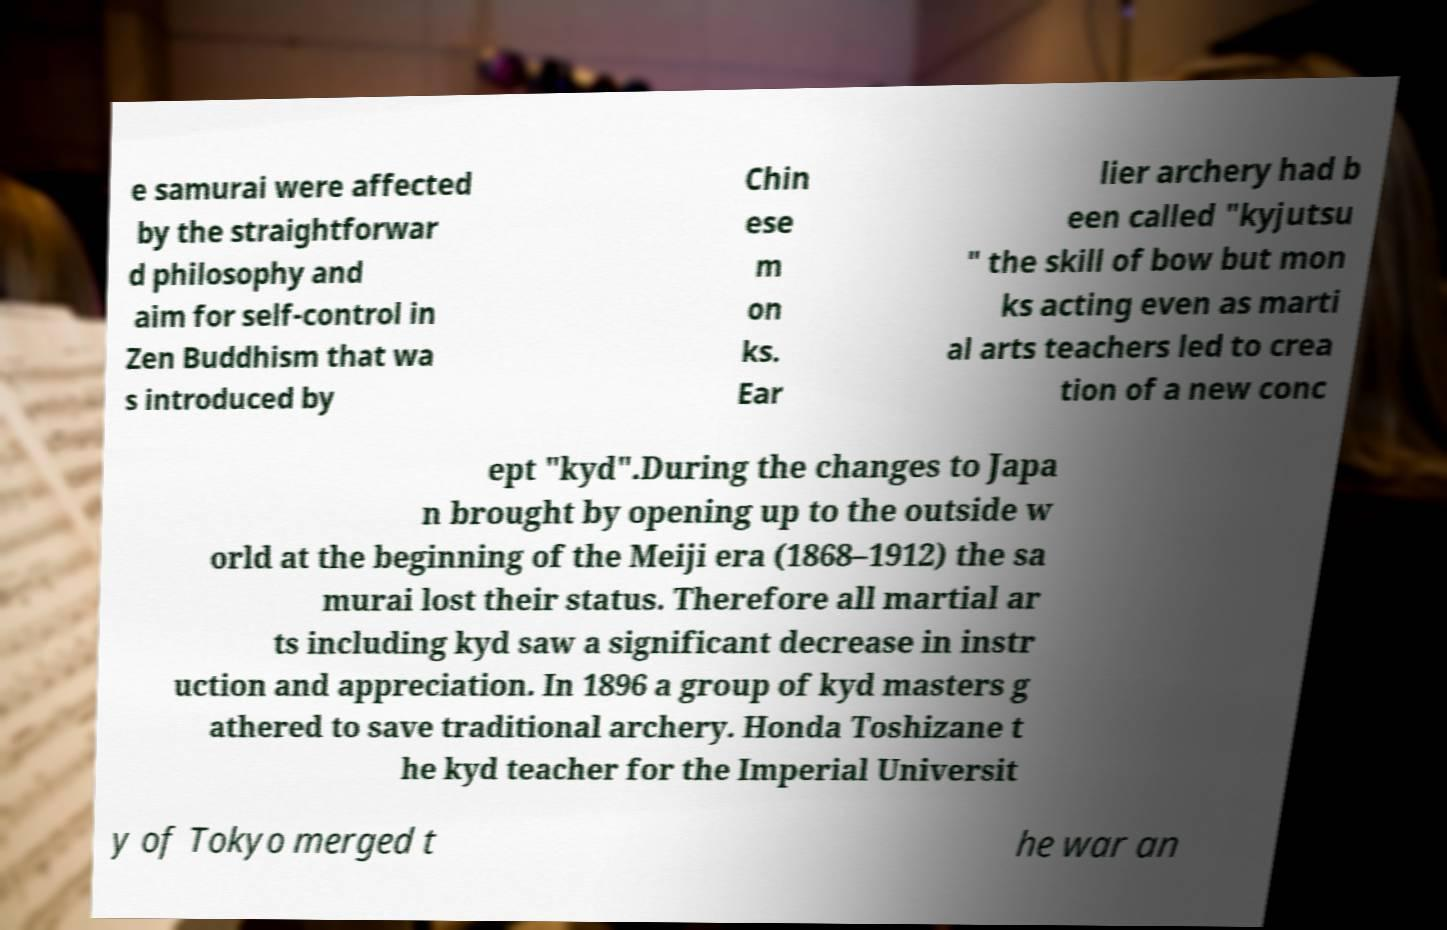Could you assist in decoding the text presented in this image and type it out clearly? e samurai were affected by the straightforwar d philosophy and aim for self-control in Zen Buddhism that wa s introduced by Chin ese m on ks. Ear lier archery had b een called "kyjutsu " the skill of bow but mon ks acting even as marti al arts teachers led to crea tion of a new conc ept "kyd".During the changes to Japa n brought by opening up to the outside w orld at the beginning of the Meiji era (1868–1912) the sa murai lost their status. Therefore all martial ar ts including kyd saw a significant decrease in instr uction and appreciation. In 1896 a group of kyd masters g athered to save traditional archery. Honda Toshizane t he kyd teacher for the Imperial Universit y of Tokyo merged t he war an 